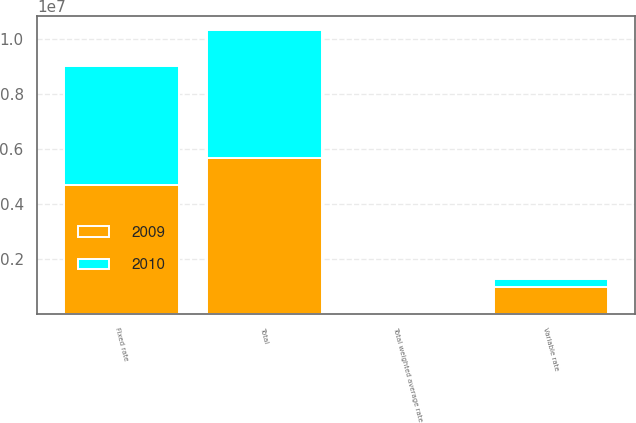<chart> <loc_0><loc_0><loc_500><loc_500><stacked_bar_chart><ecel><fcel>Fixed rate<fcel>Variable rate<fcel>Total<fcel>Total weighted average rate<nl><fcel>2010<fcel>4.35221e+06<fcel>306290<fcel>4.6585e+06<fcel>6.19<nl><fcel>2009<fcel>4.69508e+06<fcel>972427<fcel>5.66751e+06<fcel>5.65<nl></chart> 